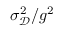<formula> <loc_0><loc_0><loc_500><loc_500>\sigma _ { \ m a t h s c r D } ^ { 2 } / g ^ { 2 }</formula> 